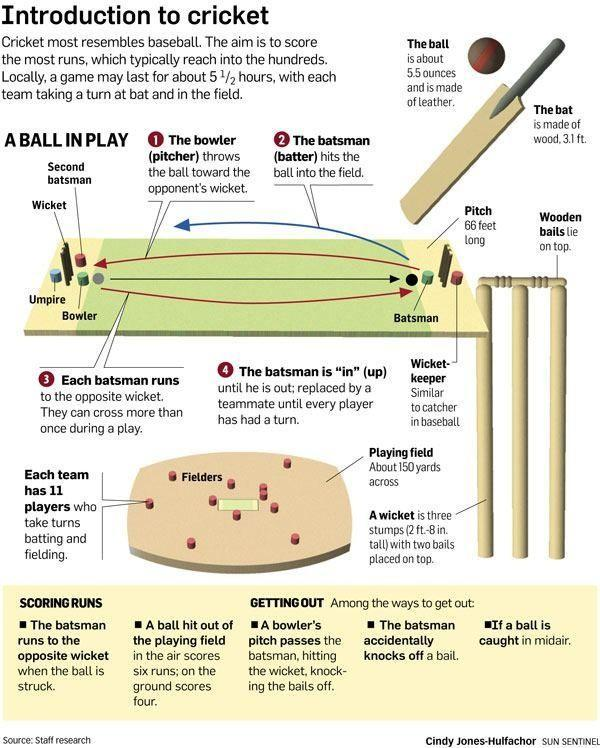Umpire represented using which color-red, blue, orange, or white?
Answer the question with a short phrase. blue Which color used to represent bowler -red, blue, green, or white? green 